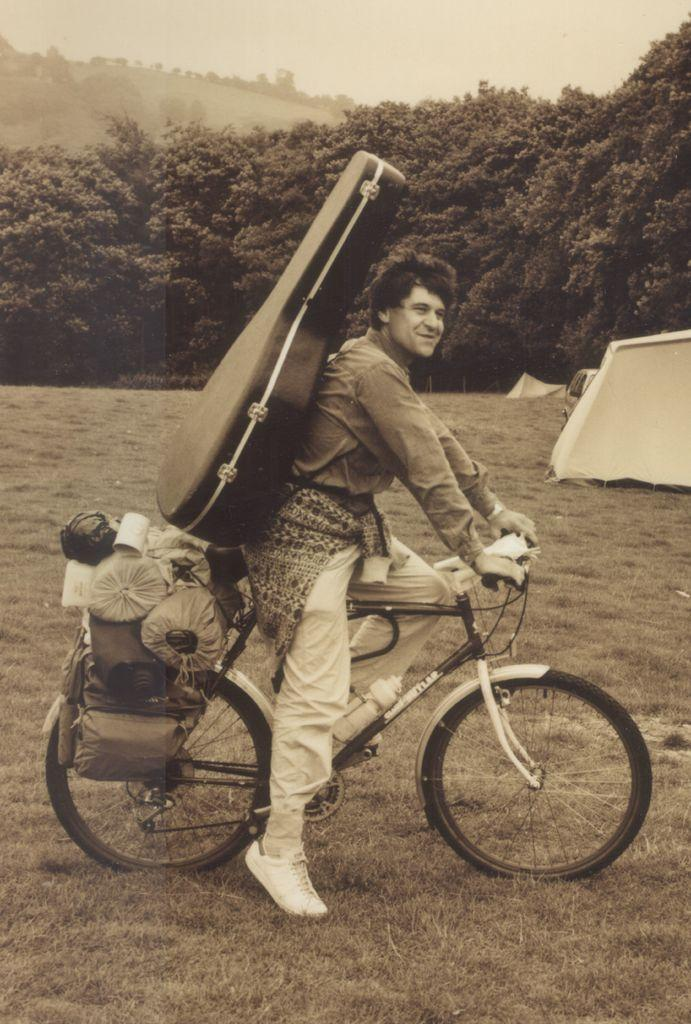What can be seen in the background of the image? There is a sky in the image, and there are trees as well. What is the man in the image doing? The man is wearing a guitar and holding a bicycle. Can you describe the man's attire in the image? The man is wearing a guitar, which suggests he might be a musician. What type of grass is the sheep eating in the image? There is no grass or sheep present in the image. Can you tell me how many teeth the man has in the image? We cannot determine the number of teeth the man has in the image, as it is not visible. 